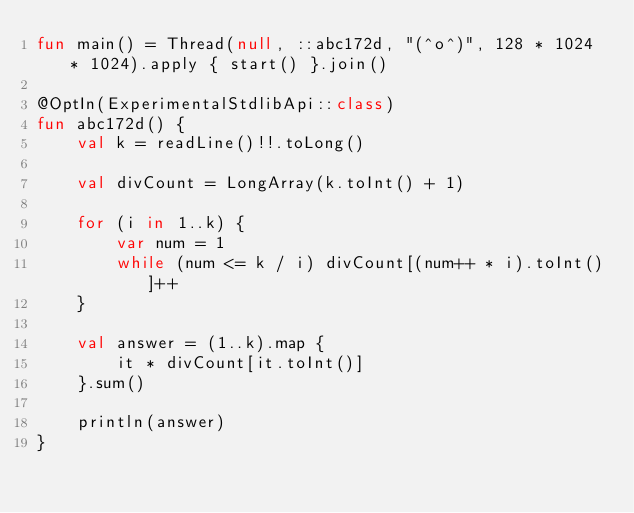<code> <loc_0><loc_0><loc_500><loc_500><_Kotlin_>fun main() = Thread(null, ::abc172d, "(^o^)", 128 * 1024 * 1024).apply { start() }.join()

@OptIn(ExperimentalStdlibApi::class)
fun abc172d() {
    val k = readLine()!!.toLong()

    val divCount = LongArray(k.toInt() + 1)

    for (i in 1..k) {
        var num = 1
        while (num <= k / i) divCount[(num++ * i).toInt()]++
    }

    val answer = (1..k).map {
        it * divCount[it.toInt()]
    }.sum()

    println(answer)
}
</code> 